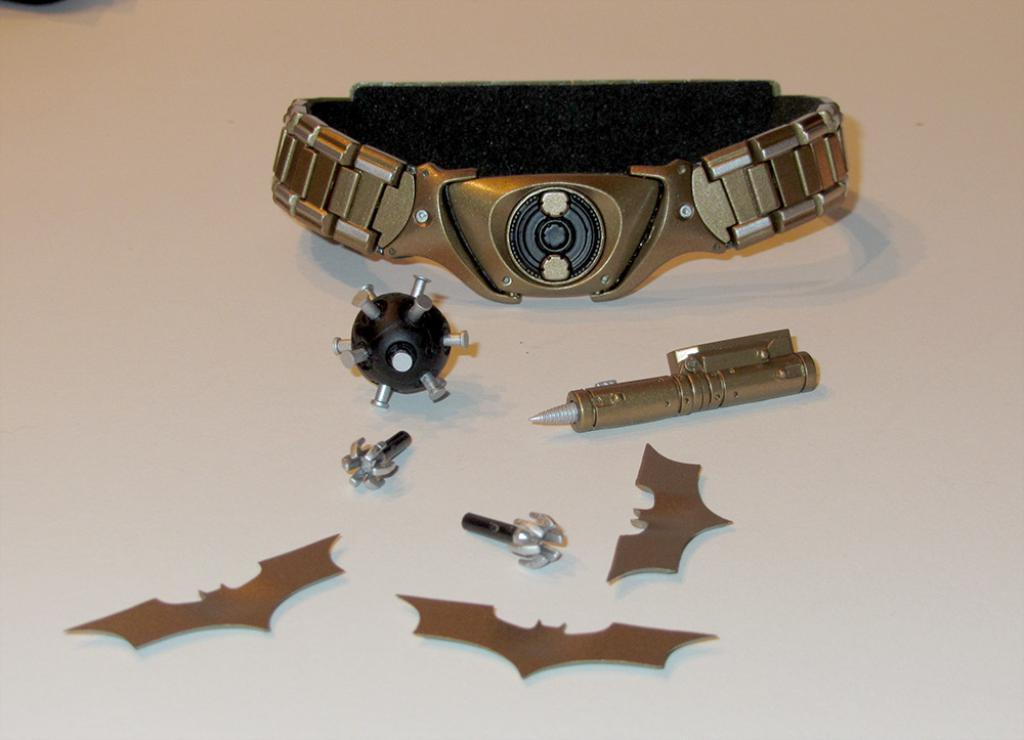What type of accessory is present in the image? There is a hand bracelet in the image. What object can be seen in the image that is typically used for playing? There is a ball in the image. What writing instrument is featured in the image? There is an iron pen in the image. What other items are present on the table in the image? The details of other items on the table are not provided, so we cannot answer this question definitively. How many pizzas are on the table in the image? There is no mention of pizzas in the image, so we cannot answer this question definitively. What type of frog can be seen interacting with the hand bracelet in the image? There is no frog present in the image, so we cannot answer this question definitively. 